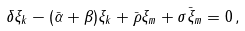<formula> <loc_0><loc_0><loc_500><loc_500>\delta \xi _ { k } - ( \bar { \alpha } + \beta ) \xi _ { k } + \bar { \rho } \xi _ { m } + \sigma \bar { \xi } _ { m } = 0 \, ,</formula> 